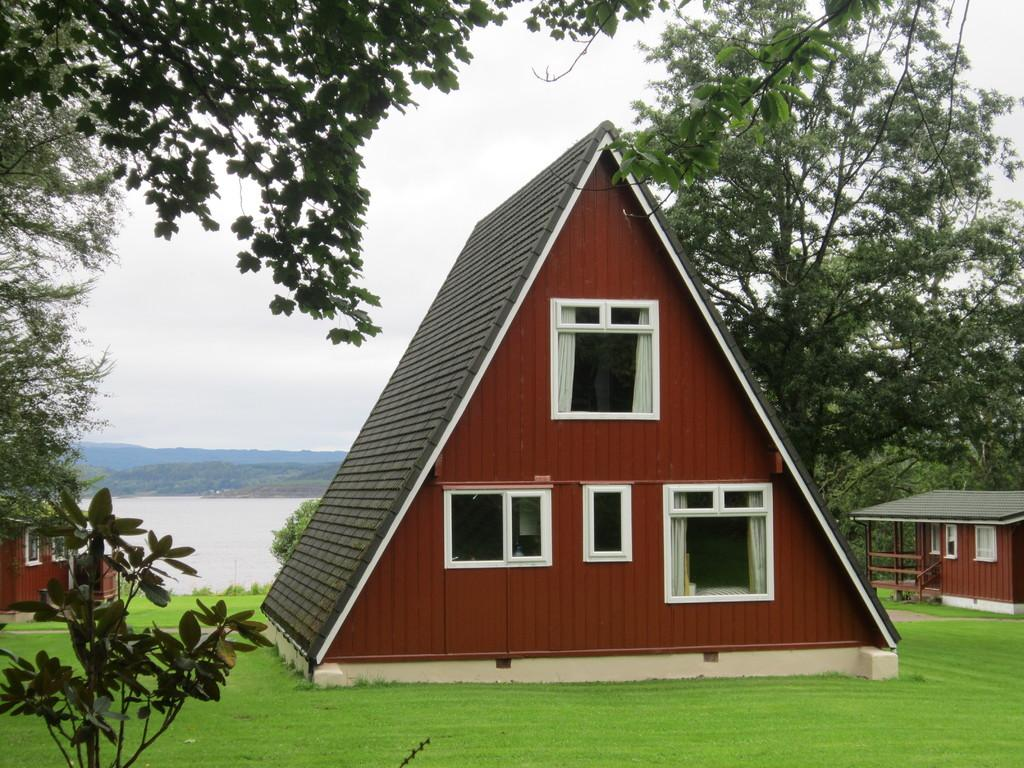What type of structures can be seen in the image? There are houses in the image. What type of vegetation is present in the image? There are trees and grass in the image. What features can be observed on the houses? The houses have windows. What can be seen in the distance in the background of the image? There are mountains, water, and the sky visible in the background of the image. What design is the camp using in the image? There is no camp present in the image, so it is not possible to determine the design being used. 